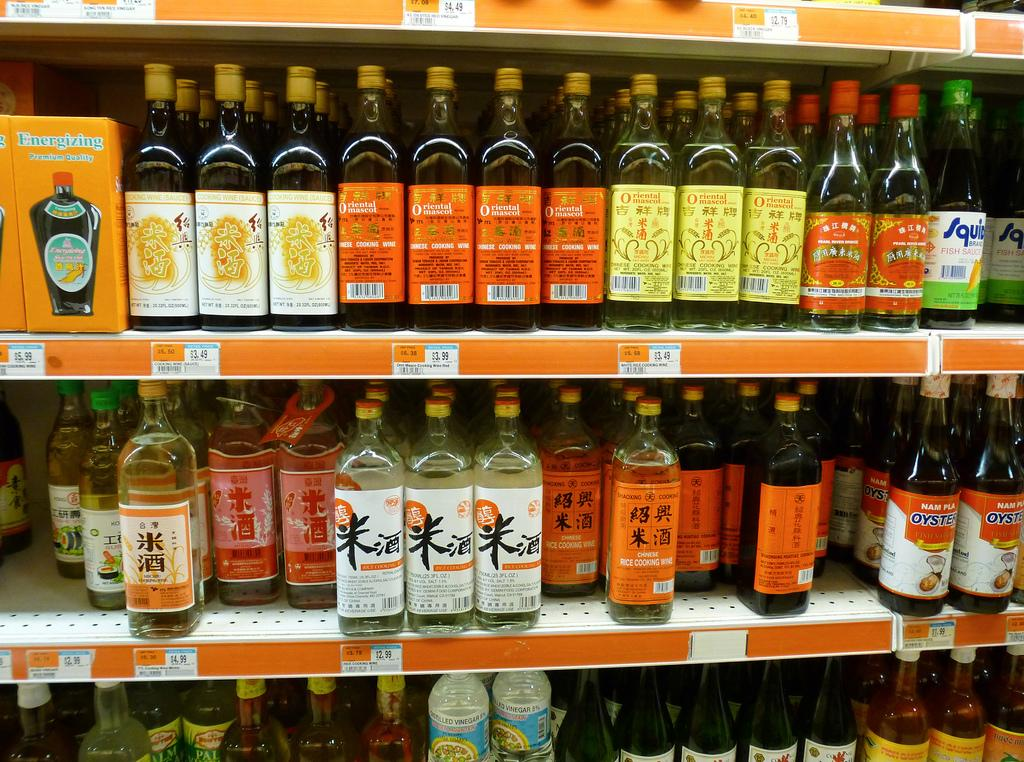What objects are present in the image? There are bottles in the image, and they are in a rack. How are the bottles organized in the rack? The bottles are labeled with different colors: orange, yellow, white, green, and blue. What other object can be seen in the image? There is a box in the image. What type of flame can be seen coming from the land in the image? There is no land or flame present in the image; it only features bottles in a rack and a box. 